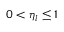<formula> <loc_0><loc_0><loc_500><loc_500>0 < \eta _ { l } \leq 1</formula> 